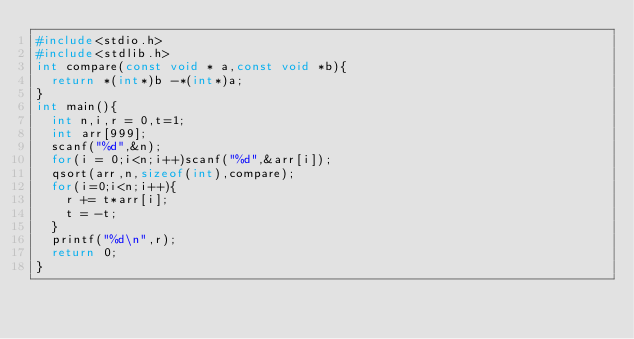Convert code to text. <code><loc_0><loc_0><loc_500><loc_500><_C_>#include<stdio.h>
#include<stdlib.h>
int compare(const void * a,const void *b){
  return *(int*)b -*(int*)a;
}
int main(){
  int n,i,r = 0,t=1;
  int arr[999];
  scanf("%d",&n);
  for(i = 0;i<n;i++)scanf("%d",&arr[i]);
  qsort(arr,n,sizeof(int),compare);
  for(i=0;i<n;i++){
    r += t*arr[i];
    t = -t;
  }
  printf("%d\n",r);
  return 0;
}
</code> 